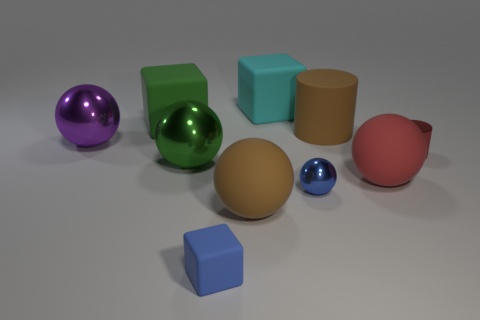How many other things are the same color as the tiny sphere?
Your answer should be compact. 1. Do the cyan object behind the red metal thing and the tiny rubber thing have the same shape?
Ensure brevity in your answer.  Yes. There is a red object that is the same shape as the big green metal thing; what is it made of?
Offer a terse response. Rubber. Is there anything else that has the same size as the blue block?
Keep it short and to the point. Yes. Are there any big cyan rubber cylinders?
Keep it short and to the point. No. What is the material of the large cube on the left side of the large brown object that is left of the blue object that is on the right side of the tiny blue rubber block?
Your response must be concise. Rubber. Do the big red rubber object and the big metal object behind the red metallic cylinder have the same shape?
Provide a short and direct response. Yes. How many big red matte objects are the same shape as the large green shiny object?
Your answer should be compact. 1. What shape is the small red object?
Offer a very short reply. Cylinder. What size is the brown object behind the big brown object that is in front of the tiny cylinder?
Make the answer very short. Large. 